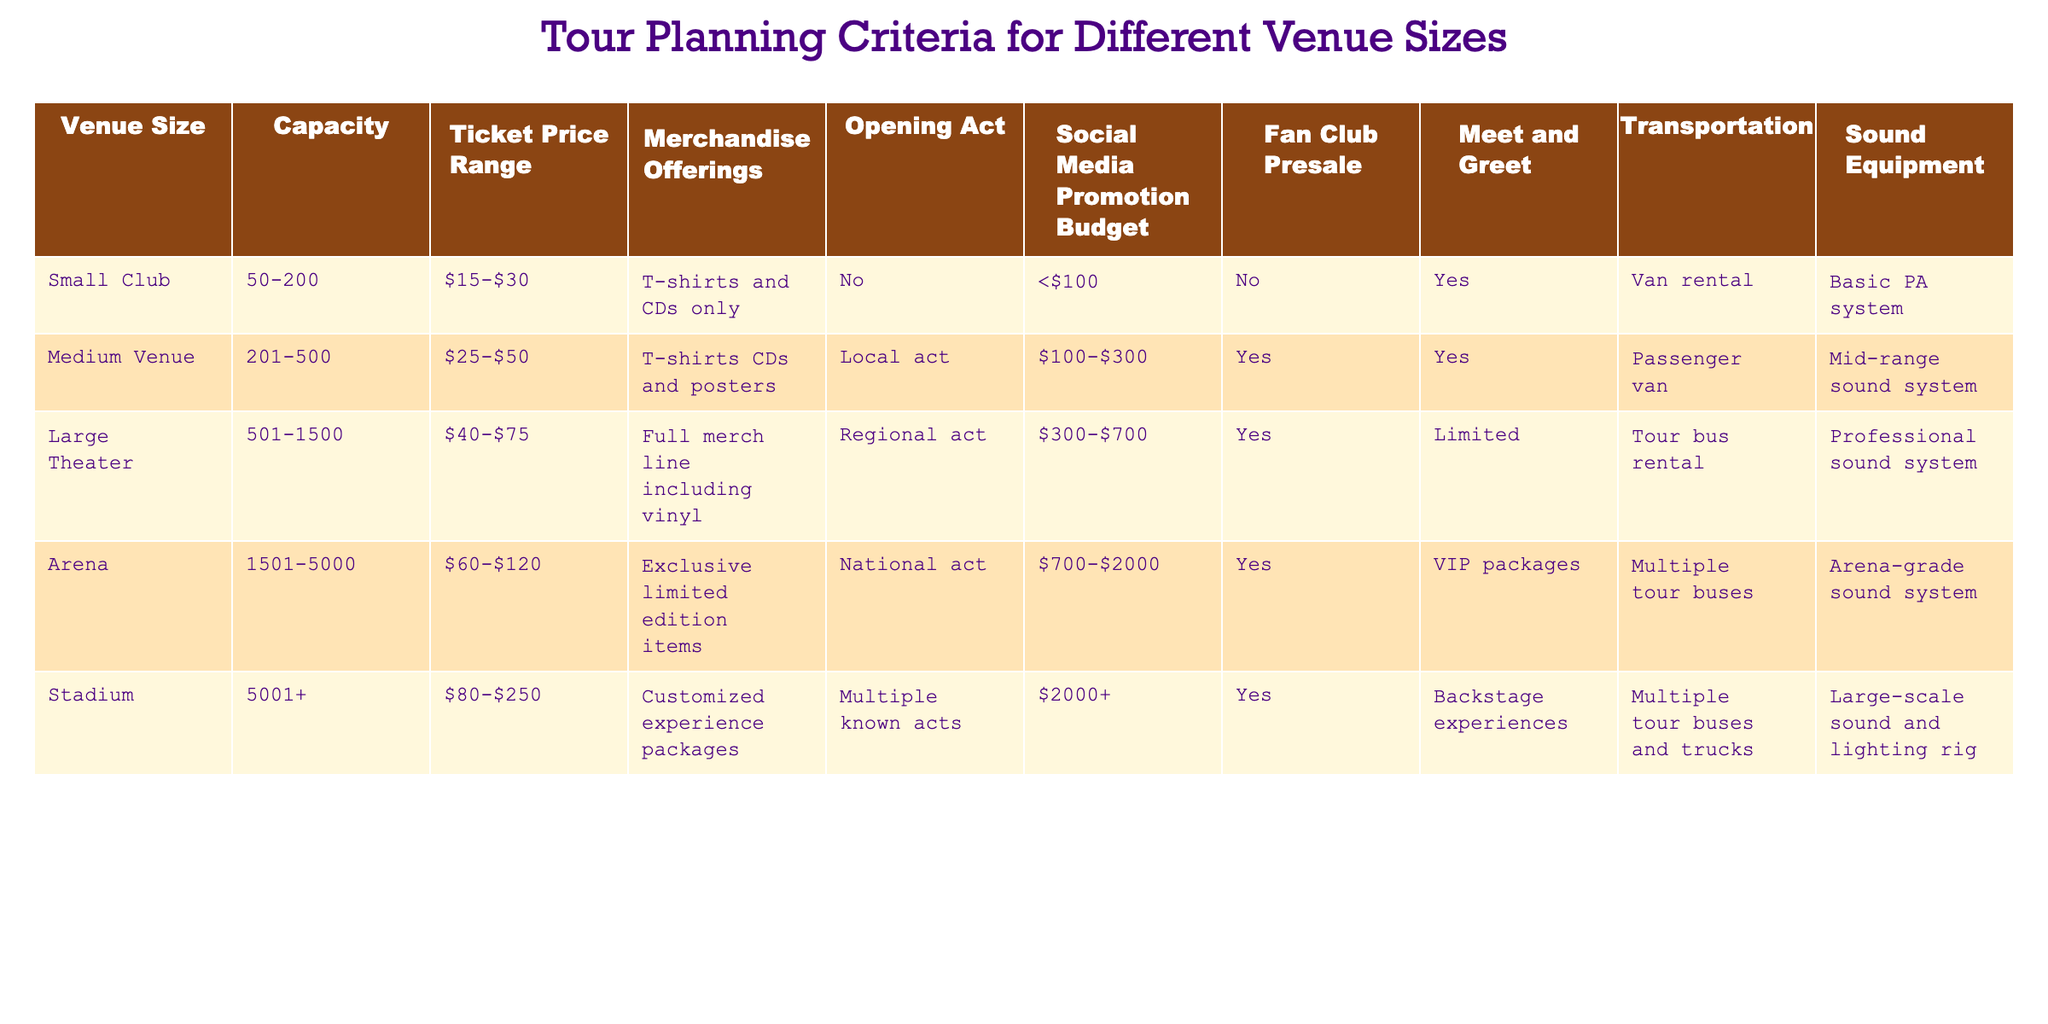What is the capacity range for a Large Theater venue? The table shows that a Large Theater has a capacity range of 501-1500. This information is directly listed under the "Capacity" column for the Large Theater row.
Answer: 501-1500 Which venue size has the highest ticket price range? According to the table, the Stadium has a ticket price range of $80-$250, which is the highest among all the venue sizes listed. This can be confirmed by comparing the "Ticket Price Range" values for each venue size.
Answer: Stadium Does a Small Club offer merchandise beyond T-shirts and CDs? The Small Club only offers T-shirts and CDs as merchandise, according to the table. This information is found in the "Merchandise Offerings" column for the Small Club row, which confirms it is a no for additional items.
Answer: No What is the total promotional budget for an Arena and a Large Theater combined? To find this, we need to read the promotional budgets from the "Social Media Promotion Budget" column for both the Arena and Large Theater. The Arena has a budget range of $700-$2000, and the Large Theater has $300-$700. To combine the ranges, we can list the lowest and highest values: $700 + $300 = $1000 (lowest) and $2000 + $700 = $2700 (highest). Therefore, the total sum of the promotional budgets combined is $1000-$2700.
Answer: $1000-$2700 Which venue offers Meet and Greet opportunities? The table indicates that the Medium Venue, Large Theater, Arena, and Stadium all offer Meet and Greet opportunities, while the Small Club does not. This comprehensive check can be done by reviewing the "Meet and Greet" column for each venue's row.
Answer: Medium Venue, Large Theater, Arena, Stadium What is the average capacity of all venue sizes? To find the average capacity, we first need to convert the capacity ranges into numeric values: Small Club (125), Medium Venue (350), Large Theater (1000), Arena (3250), and Stadium (5001). We then sum these values: 125 + 350 + 1000 + 3250 + 5001 = 9916. There are 5 venues, so the average capacity is 9916 / 5 = 1983.2.
Answer: 1983.2 Is there a Small Club that has an Opening Act? Looking at the table, it's clear that the Small Club does not have an Opening Act listed. The specific row shows "No" under the "Opening Act" column for the Small Club, indicating there is no opening act for that venue size.
Answer: No Which venue has the most extensive merchandise offerings? The Stadium is listed as having "Customized experience packages" in the "Merchandise Offerings" column, which is the most extensive compared to other venues. By examining the offerings in the table, it's evident that the Stadium provides unique and extensive items.
Answer: Stadium 